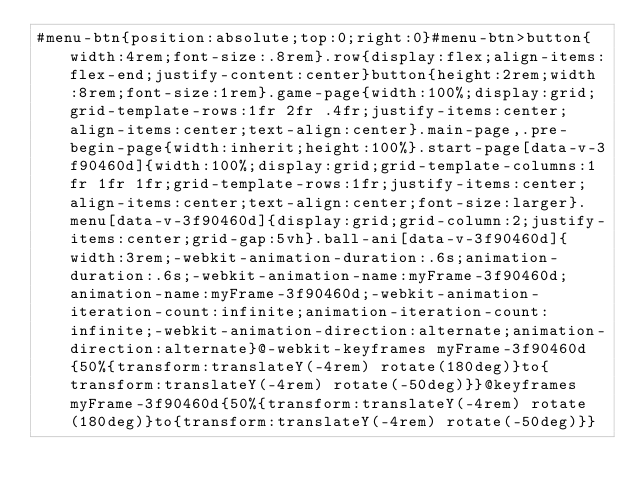<code> <loc_0><loc_0><loc_500><loc_500><_CSS_>#menu-btn{position:absolute;top:0;right:0}#menu-btn>button{width:4rem;font-size:.8rem}.row{display:flex;align-items:flex-end;justify-content:center}button{height:2rem;width:8rem;font-size:1rem}.game-page{width:100%;display:grid;grid-template-rows:1fr 2fr .4fr;justify-items:center;align-items:center;text-align:center}.main-page,.pre-begin-page{width:inherit;height:100%}.start-page[data-v-3f90460d]{width:100%;display:grid;grid-template-columns:1fr 1fr 1fr;grid-template-rows:1fr;justify-items:center;align-items:center;text-align:center;font-size:larger}.menu[data-v-3f90460d]{display:grid;grid-column:2;justify-items:center;grid-gap:5vh}.ball-ani[data-v-3f90460d]{width:3rem;-webkit-animation-duration:.6s;animation-duration:.6s;-webkit-animation-name:myFrame-3f90460d;animation-name:myFrame-3f90460d;-webkit-animation-iteration-count:infinite;animation-iteration-count:infinite;-webkit-animation-direction:alternate;animation-direction:alternate}@-webkit-keyframes myFrame-3f90460d{50%{transform:translateY(-4rem) rotate(180deg)}to{transform:translateY(-4rem) rotate(-50deg)}}@keyframes myFrame-3f90460d{50%{transform:translateY(-4rem) rotate(180deg)}to{transform:translateY(-4rem) rotate(-50deg)}}</code> 